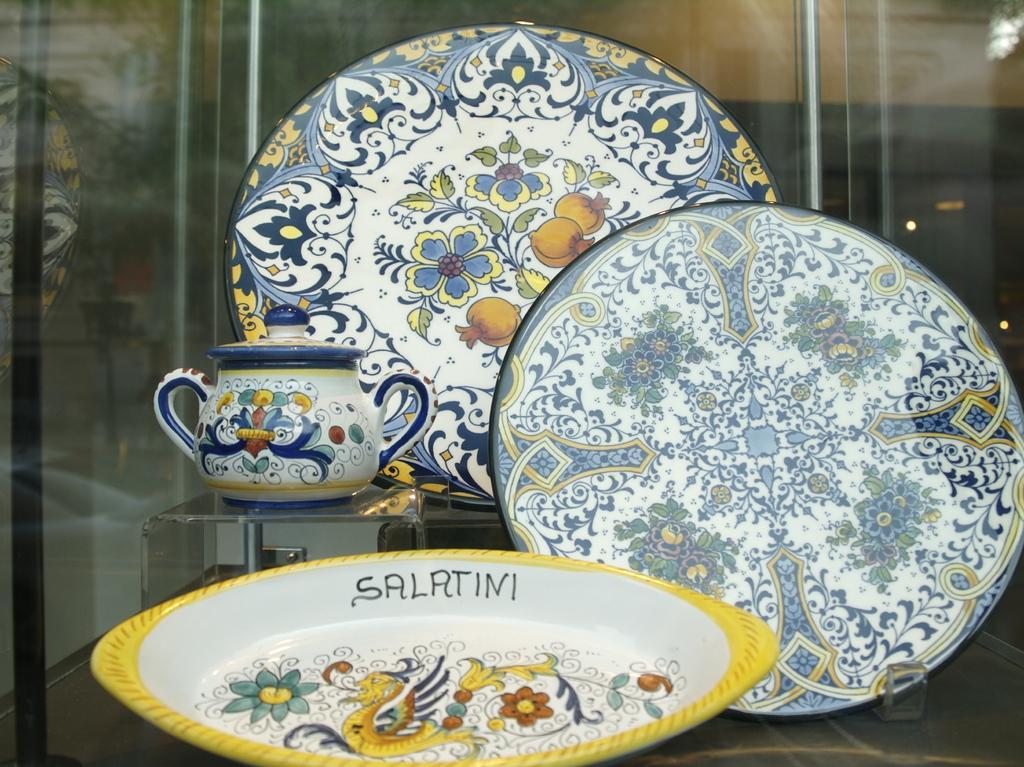Can you describe this image briefly? This picture shows few trays and a jar. we see designs on them. 